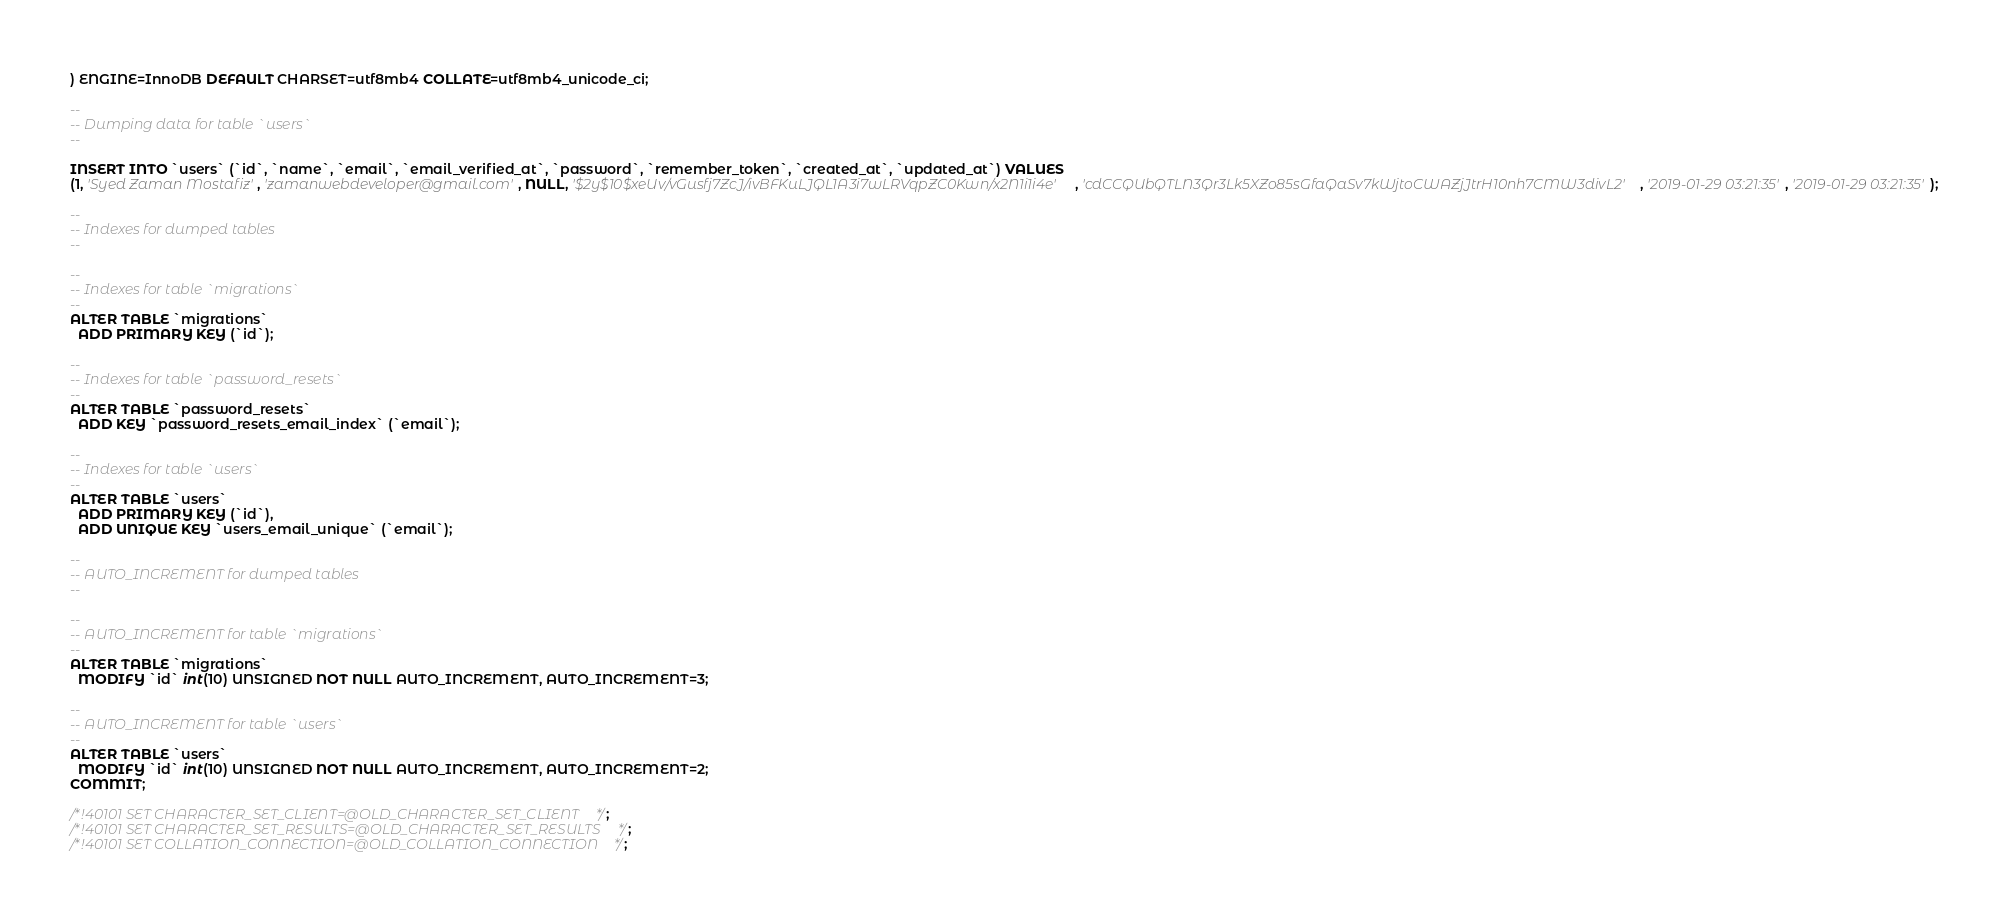Convert code to text. <code><loc_0><loc_0><loc_500><loc_500><_SQL_>) ENGINE=InnoDB DEFAULT CHARSET=utf8mb4 COLLATE=utf8mb4_unicode_ci;

--
-- Dumping data for table `users`
--

INSERT INTO `users` (`id`, `name`, `email`, `email_verified_at`, `password`, `remember_token`, `created_at`, `updated_at`) VALUES
(1, 'Syed Zaman Mostafiz', 'zamanwebdeveloper@gmail.com', NULL, '$2y$10$xeUv/vGusfj7ZcJ/ivBFKuLJQL1A3i7wLRVqpZC0Kwn/x2N1i1i4e', 'cdCCQUbQTLN3Qr3Lk5XZo85sGfaQaSv7kWjtoCWAZjJtrH10nh7CMW3divL2', '2019-01-29 03:21:35', '2019-01-29 03:21:35');

--
-- Indexes for dumped tables
--

--
-- Indexes for table `migrations`
--
ALTER TABLE `migrations`
  ADD PRIMARY KEY (`id`);

--
-- Indexes for table `password_resets`
--
ALTER TABLE `password_resets`
  ADD KEY `password_resets_email_index` (`email`);

--
-- Indexes for table `users`
--
ALTER TABLE `users`
  ADD PRIMARY KEY (`id`),
  ADD UNIQUE KEY `users_email_unique` (`email`);

--
-- AUTO_INCREMENT for dumped tables
--

--
-- AUTO_INCREMENT for table `migrations`
--
ALTER TABLE `migrations`
  MODIFY `id` int(10) UNSIGNED NOT NULL AUTO_INCREMENT, AUTO_INCREMENT=3;

--
-- AUTO_INCREMENT for table `users`
--
ALTER TABLE `users`
  MODIFY `id` int(10) UNSIGNED NOT NULL AUTO_INCREMENT, AUTO_INCREMENT=2;
COMMIT;

/*!40101 SET CHARACTER_SET_CLIENT=@OLD_CHARACTER_SET_CLIENT */;
/*!40101 SET CHARACTER_SET_RESULTS=@OLD_CHARACTER_SET_RESULTS */;
/*!40101 SET COLLATION_CONNECTION=@OLD_COLLATION_CONNECTION */;
</code> 